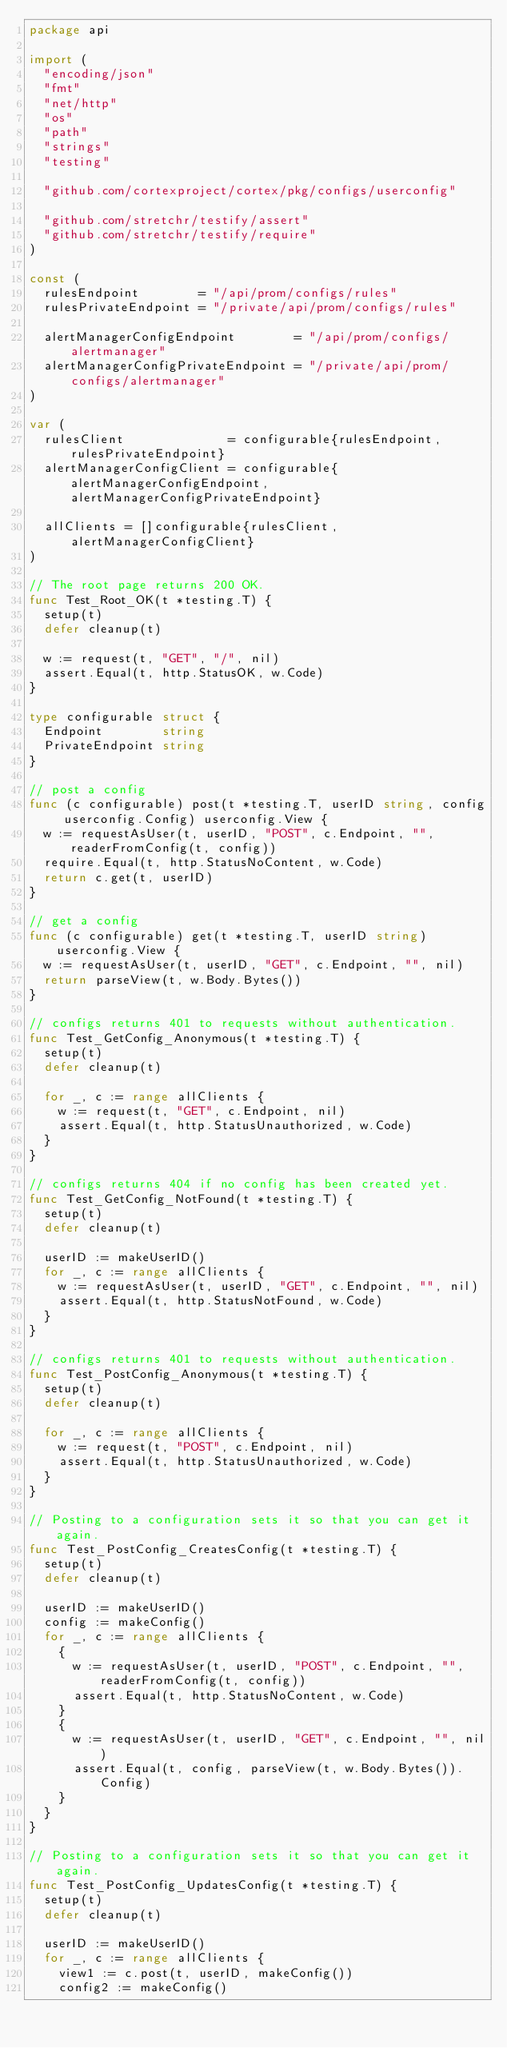<code> <loc_0><loc_0><loc_500><loc_500><_Go_>package api

import (
	"encoding/json"
	"fmt"
	"net/http"
	"os"
	"path"
	"strings"
	"testing"

	"github.com/cortexproject/cortex/pkg/configs/userconfig"

	"github.com/stretchr/testify/assert"
	"github.com/stretchr/testify/require"
)

const (
	rulesEndpoint        = "/api/prom/configs/rules"
	rulesPrivateEndpoint = "/private/api/prom/configs/rules"

	alertManagerConfigEndpoint        = "/api/prom/configs/alertmanager"
	alertManagerConfigPrivateEndpoint = "/private/api/prom/configs/alertmanager"
)

var (
	rulesClient              = configurable{rulesEndpoint, rulesPrivateEndpoint}
	alertManagerConfigClient = configurable{alertManagerConfigEndpoint, alertManagerConfigPrivateEndpoint}

	allClients = []configurable{rulesClient, alertManagerConfigClient}
)

// The root page returns 200 OK.
func Test_Root_OK(t *testing.T) {
	setup(t)
	defer cleanup(t)

	w := request(t, "GET", "/", nil)
	assert.Equal(t, http.StatusOK, w.Code)
}

type configurable struct {
	Endpoint        string
	PrivateEndpoint string
}

// post a config
func (c configurable) post(t *testing.T, userID string, config userconfig.Config) userconfig.View {
	w := requestAsUser(t, userID, "POST", c.Endpoint, "", readerFromConfig(t, config))
	require.Equal(t, http.StatusNoContent, w.Code)
	return c.get(t, userID)
}

// get a config
func (c configurable) get(t *testing.T, userID string) userconfig.View {
	w := requestAsUser(t, userID, "GET", c.Endpoint, "", nil)
	return parseView(t, w.Body.Bytes())
}

// configs returns 401 to requests without authentication.
func Test_GetConfig_Anonymous(t *testing.T) {
	setup(t)
	defer cleanup(t)

	for _, c := range allClients {
		w := request(t, "GET", c.Endpoint, nil)
		assert.Equal(t, http.StatusUnauthorized, w.Code)
	}
}

// configs returns 404 if no config has been created yet.
func Test_GetConfig_NotFound(t *testing.T) {
	setup(t)
	defer cleanup(t)

	userID := makeUserID()
	for _, c := range allClients {
		w := requestAsUser(t, userID, "GET", c.Endpoint, "", nil)
		assert.Equal(t, http.StatusNotFound, w.Code)
	}
}

// configs returns 401 to requests without authentication.
func Test_PostConfig_Anonymous(t *testing.T) {
	setup(t)
	defer cleanup(t)

	for _, c := range allClients {
		w := request(t, "POST", c.Endpoint, nil)
		assert.Equal(t, http.StatusUnauthorized, w.Code)
	}
}

// Posting to a configuration sets it so that you can get it again.
func Test_PostConfig_CreatesConfig(t *testing.T) {
	setup(t)
	defer cleanup(t)

	userID := makeUserID()
	config := makeConfig()
	for _, c := range allClients {
		{
			w := requestAsUser(t, userID, "POST", c.Endpoint, "", readerFromConfig(t, config))
			assert.Equal(t, http.StatusNoContent, w.Code)
		}
		{
			w := requestAsUser(t, userID, "GET", c.Endpoint, "", nil)
			assert.Equal(t, config, parseView(t, w.Body.Bytes()).Config)
		}
	}
}

// Posting to a configuration sets it so that you can get it again.
func Test_PostConfig_UpdatesConfig(t *testing.T) {
	setup(t)
	defer cleanup(t)

	userID := makeUserID()
	for _, c := range allClients {
		view1 := c.post(t, userID, makeConfig())
		config2 := makeConfig()</code> 